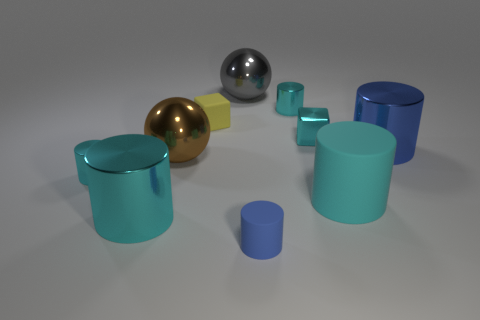The metallic block that is the same color as the large matte cylinder is what size?
Your answer should be compact. Small. There is a cube that is right of the tiny blue object; what is it made of?
Offer a terse response. Metal. The matte cube is what color?
Offer a terse response. Yellow. There is a ball in front of the large gray metal sphere; does it have the same size as the cube that is in front of the small yellow object?
Offer a terse response. No. There is a thing that is behind the big brown metal thing and right of the tiny cyan metal cube; how big is it?
Offer a very short reply. Large. There is a big matte object that is the same shape as the tiny blue matte thing; what is its color?
Keep it short and to the point. Cyan. Is the number of cyan matte cylinders that are left of the big rubber cylinder greater than the number of tiny cyan cylinders on the left side of the big brown ball?
Offer a terse response. No. How many other things are there of the same shape as the large gray shiny thing?
Your answer should be compact. 1. Is there a cylinder that is left of the big metal object that is right of the tiny cyan cube?
Provide a short and direct response. Yes. How many large blue cylinders are there?
Your answer should be very brief. 1. 